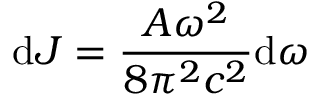<formula> <loc_0><loc_0><loc_500><loc_500>d J = \frac { A \omega ^ { 2 } } { 8 \pi ^ { 2 } c ^ { 2 } } d \omega</formula> 